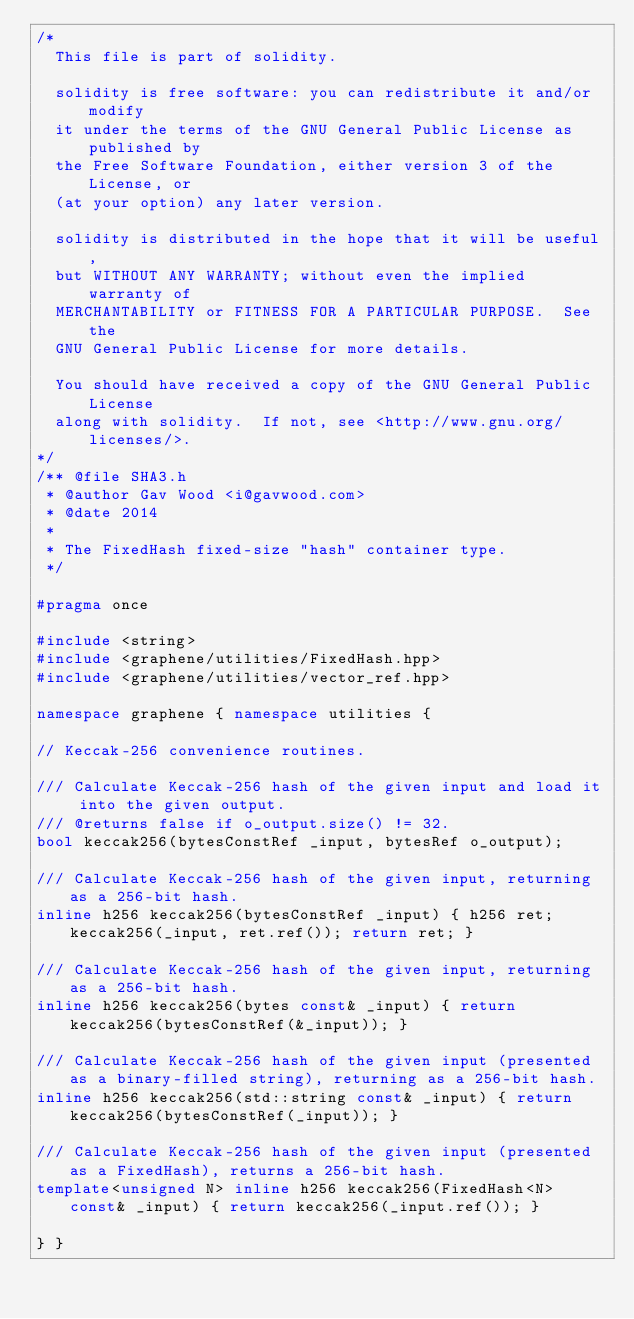Convert code to text. <code><loc_0><loc_0><loc_500><loc_500><_C++_>/*
	This file is part of solidity.

	solidity is free software: you can redistribute it and/or modify
	it under the terms of the GNU General Public License as published by
	the Free Software Foundation, either version 3 of the License, or
	(at your option) any later version.

	solidity is distributed in the hope that it will be useful,
	but WITHOUT ANY WARRANTY; without even the implied warranty of
	MERCHANTABILITY or FITNESS FOR A PARTICULAR PURPOSE.  See the
	GNU General Public License for more details.

	You should have received a copy of the GNU General Public License
	along with solidity.  If not, see <http://www.gnu.org/licenses/>.
*/
/** @file SHA3.h
 * @author Gav Wood <i@gavwood.com>
 * @date 2014
 *
 * The FixedHash fixed-size "hash" container type.
 */

#pragma once

#include <string>
#include <graphene/utilities/FixedHash.hpp>
#include <graphene/utilities/vector_ref.hpp>

namespace graphene { namespace utilities {

// Keccak-256 convenience routines.

/// Calculate Keccak-256 hash of the given input and load it into the given output.
/// @returns false if o_output.size() != 32.
bool keccak256(bytesConstRef _input, bytesRef o_output);

/// Calculate Keccak-256 hash of the given input, returning as a 256-bit hash.
inline h256 keccak256(bytesConstRef _input) { h256 ret; keccak256(_input, ret.ref()); return ret; }

/// Calculate Keccak-256 hash of the given input, returning as a 256-bit hash.
inline h256 keccak256(bytes const& _input) { return keccak256(bytesConstRef(&_input)); }

/// Calculate Keccak-256 hash of the given input (presented as a binary-filled string), returning as a 256-bit hash.
inline h256 keccak256(std::string const& _input) { return keccak256(bytesConstRef(_input)); }

/// Calculate Keccak-256 hash of the given input (presented as a FixedHash), returns a 256-bit hash.
template<unsigned N> inline h256 keccak256(FixedHash<N> const& _input) { return keccak256(_input.ref()); }

} }
</code> 